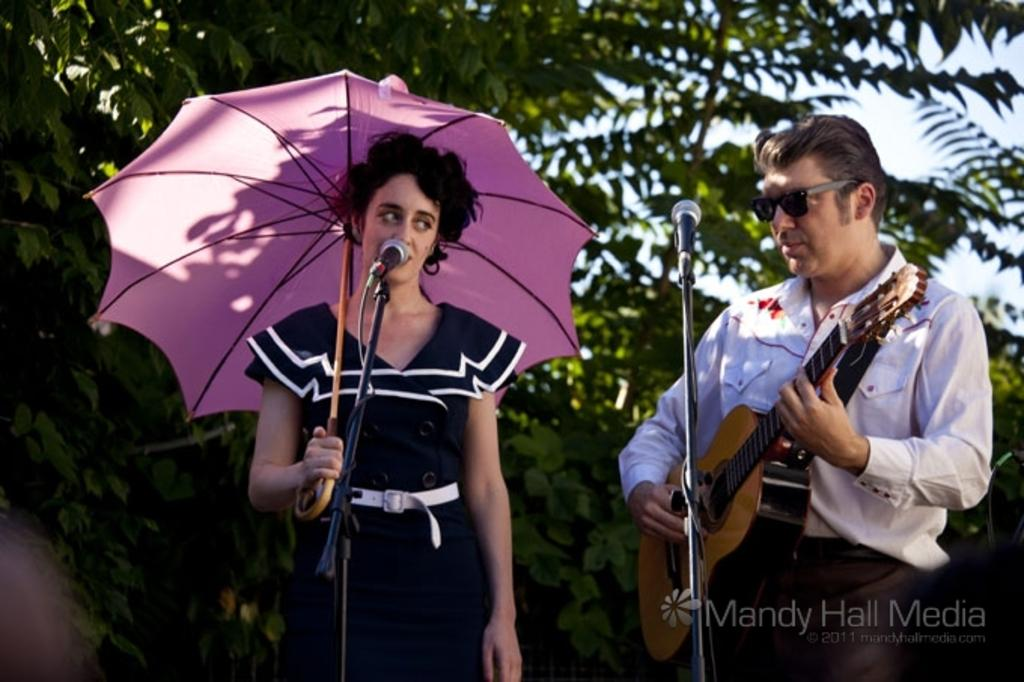How many people are in the image? There are two people in the image. Can you describe the gender of the people? One of the people is a woman, and the other person is a man. What is the woman holding in the image? The woman is holding an umbrella. What is the man holding in the image? The man is holding a guitar. How many kittens are being washed in the image? There are no kittens or washing activities present in the image. 